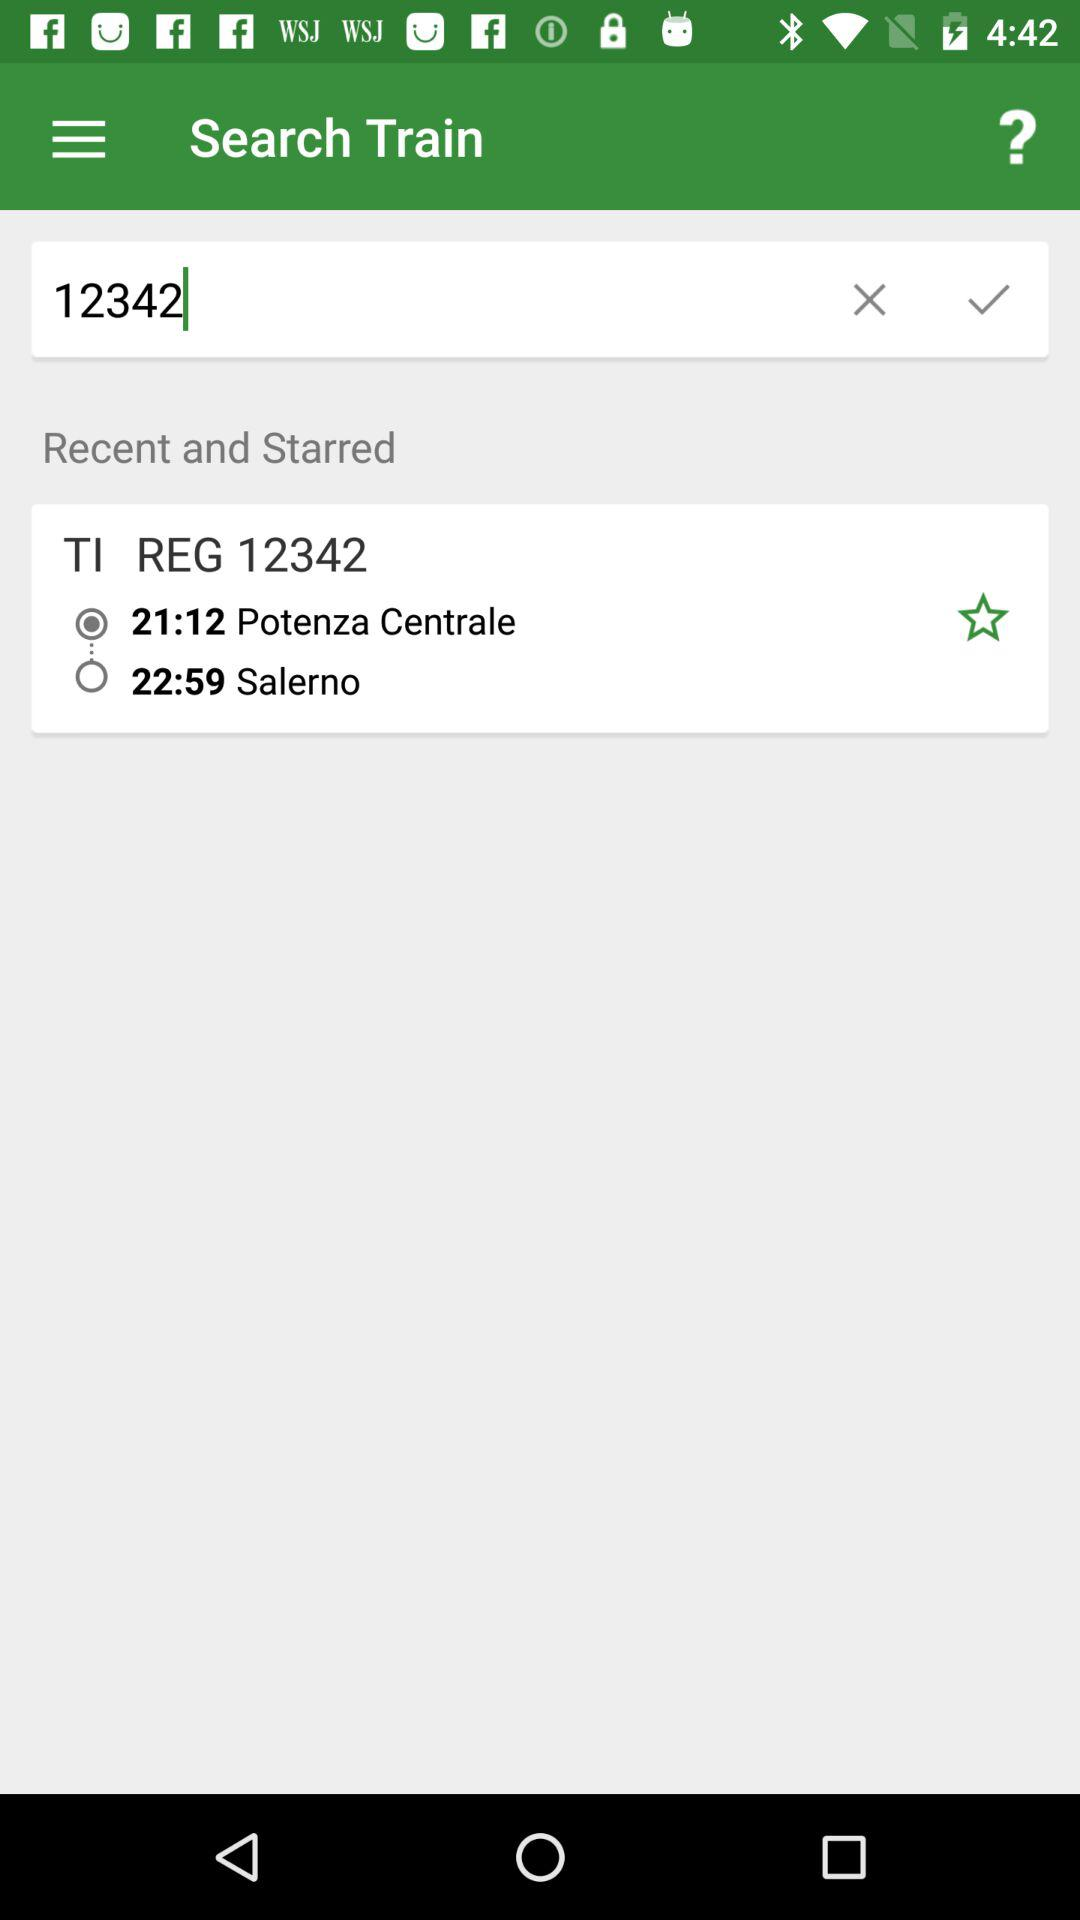Which option is selected for TI REG12342?
When the provided information is insufficient, respond with <no answer>. <no answer> 